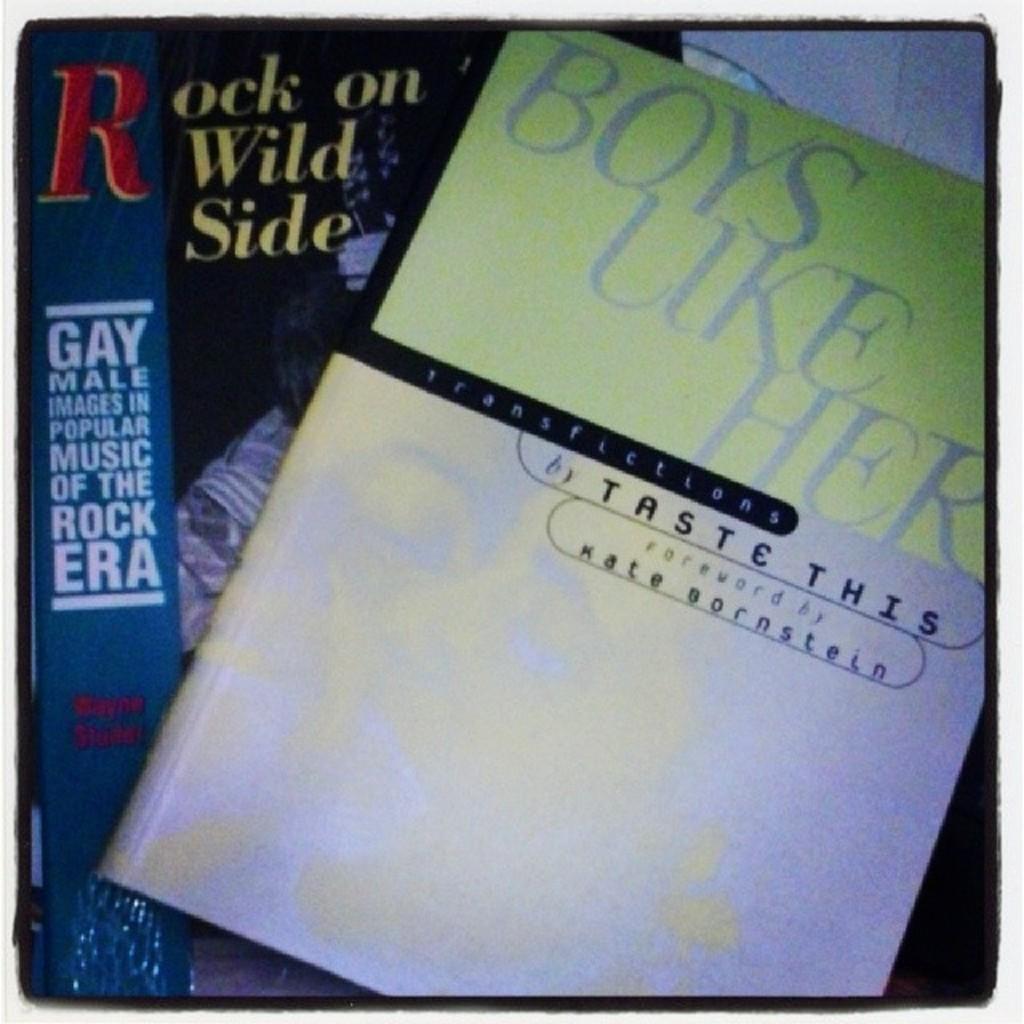Who wrote the book?
Your response must be concise. Taste this. What is the author of boys like her?
Offer a terse response. Taste this. 